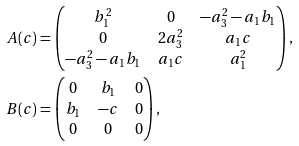Convert formula to latex. <formula><loc_0><loc_0><loc_500><loc_500>A ( c ) & = \begin{pmatrix} b _ { 1 } ^ { 2 } & 0 & - a _ { 3 } ^ { 2 } - a _ { 1 } b _ { 1 } \\ 0 & 2 a _ { 3 } ^ { 2 } & a _ { 1 } c \\ - a _ { 3 } ^ { 2 } - a _ { 1 } b _ { 1 } & a _ { 1 } c & a _ { 1 } ^ { 2 } \end{pmatrix} , \\ B ( c ) & = \begin{pmatrix} 0 & b _ { 1 } & 0 \\ b _ { 1 } & - c & 0 \\ 0 & 0 & 0 \\ \end{pmatrix} ,</formula> 